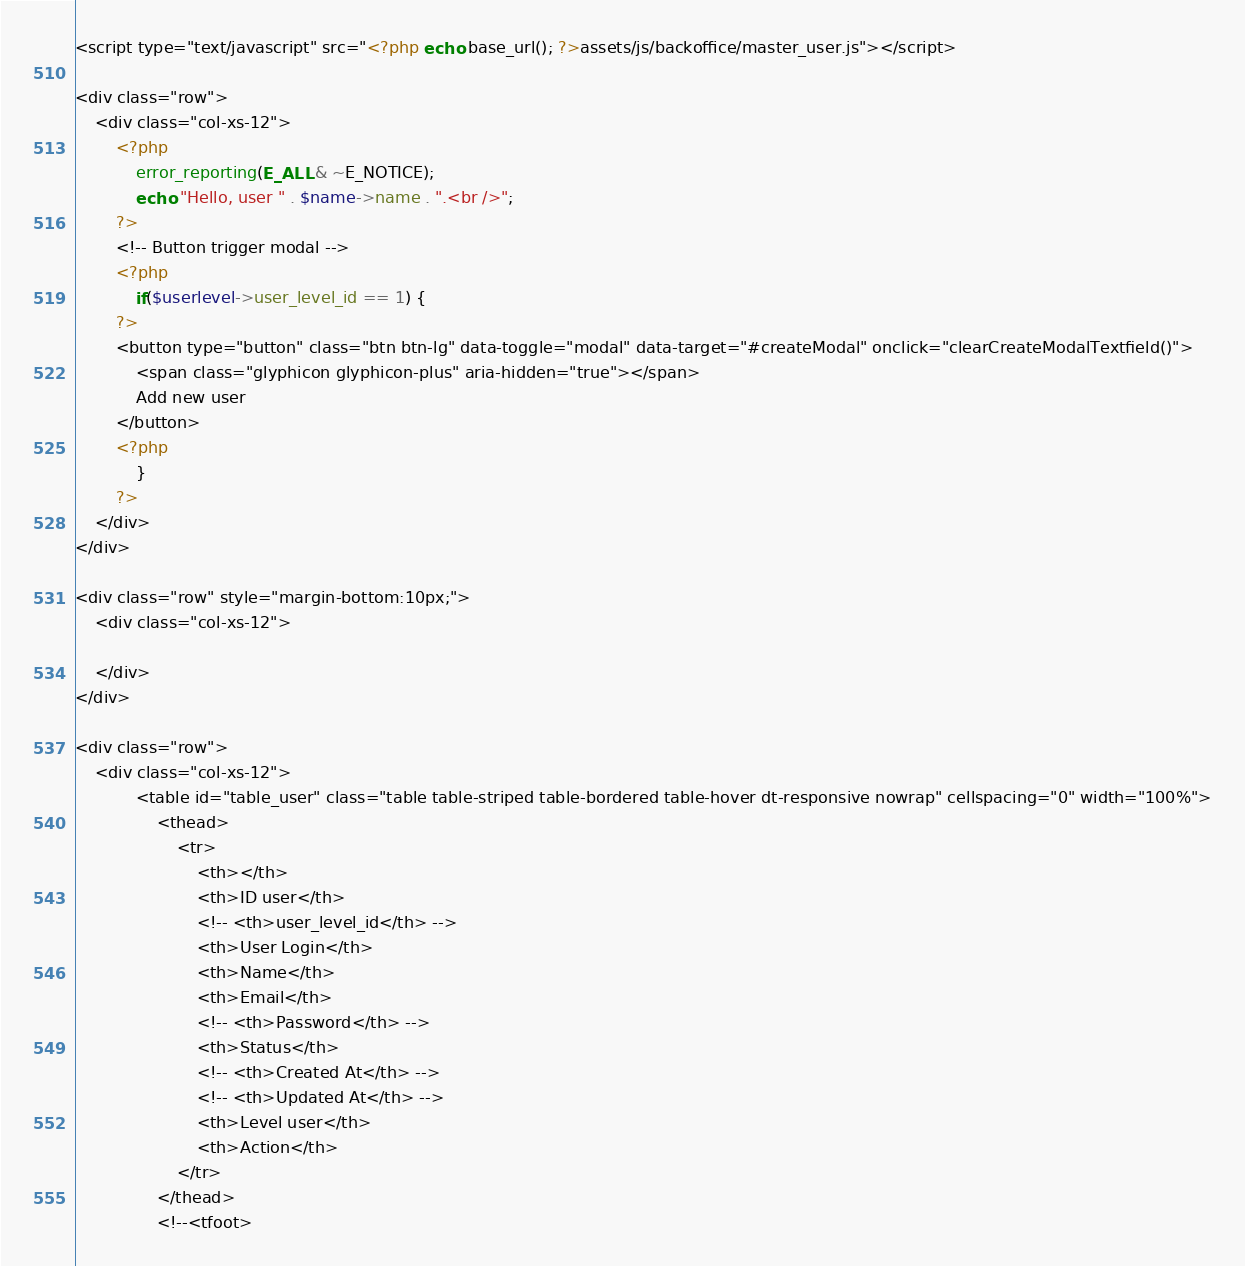<code> <loc_0><loc_0><loc_500><loc_500><_PHP_><script type="text/javascript" src="<?php echo base_url(); ?>assets/js/backoffice/master_user.js"></script>

<div class="row">
    <div class="col-xs-12">
        <?php
            error_reporting(E_ALL & ~E_NOTICE);
            echo "Hello, user " . $name->name . ".<br />";
        ?>
        <!-- Button trigger modal -->
        <?php
            if($userlevel->user_level_id == 1) {
        ?>
        <button type="button" class="btn btn-lg" data-toggle="modal" data-target="#createModal" onclick="clearCreateModalTextfield()">
            <span class="glyphicon glyphicon-plus" aria-hidden="true"></span>
            Add new user
        </button>
        <?php
            }
        ?>
    </div>
</div>

<div class="row" style="margin-bottom:10px;">
    <div class="col-xs-12">
        
    </div>
</div>

<div class="row">
    <div class="col-xs-12">
            <table id="table_user" class="table table-striped table-bordered table-hover dt-responsive nowrap" cellspacing="0" width="100%">
                <thead>
                    <tr>
                        <th></th>
                        <th>ID user</th>
                        <!-- <th>user_level_id</th> -->
                        <th>User Login</th>
                        <th>Name</th>
                        <th>Email</th>
                        <!-- <th>Password</th> -->
                        <th>Status</th>
                        <!-- <th>Created At</th> -->
                        <!-- <th>Updated At</th> -->
                        <th>Level user</th>
                        <th>Action</th>
                    </tr>
                </thead>
                <!--<tfoot></code> 